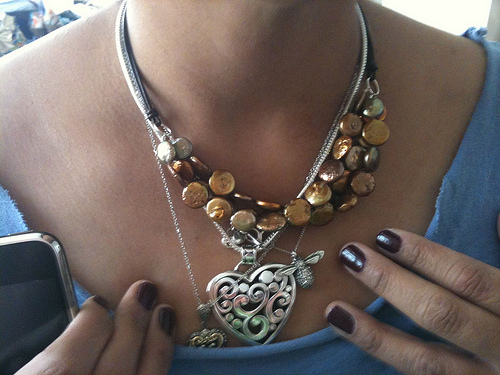<image>
Can you confirm if the pendant is on the chain? Yes. Looking at the image, I can see the pendant is positioned on top of the chain, with the chain providing support. 